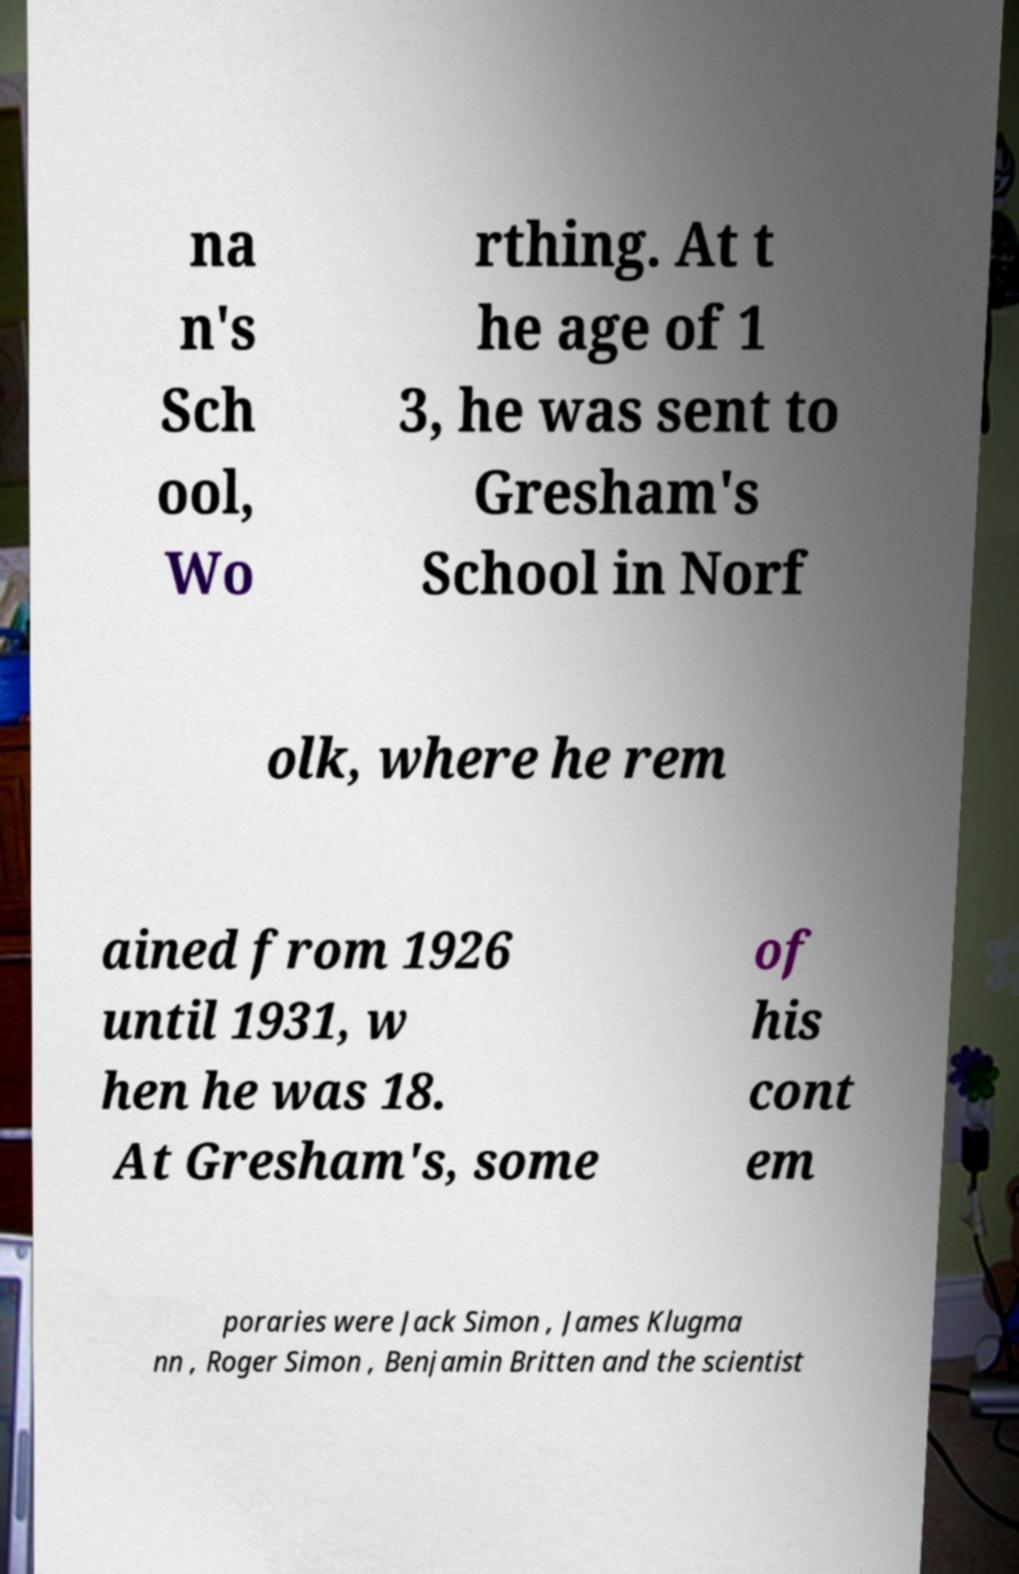Please read and relay the text visible in this image. What does it say? na n's Sch ool, Wo rthing. At t he age of 1 3, he was sent to Gresham's School in Norf olk, where he rem ained from 1926 until 1931, w hen he was 18. At Gresham's, some of his cont em poraries were Jack Simon , James Klugma nn , Roger Simon , Benjamin Britten and the scientist 